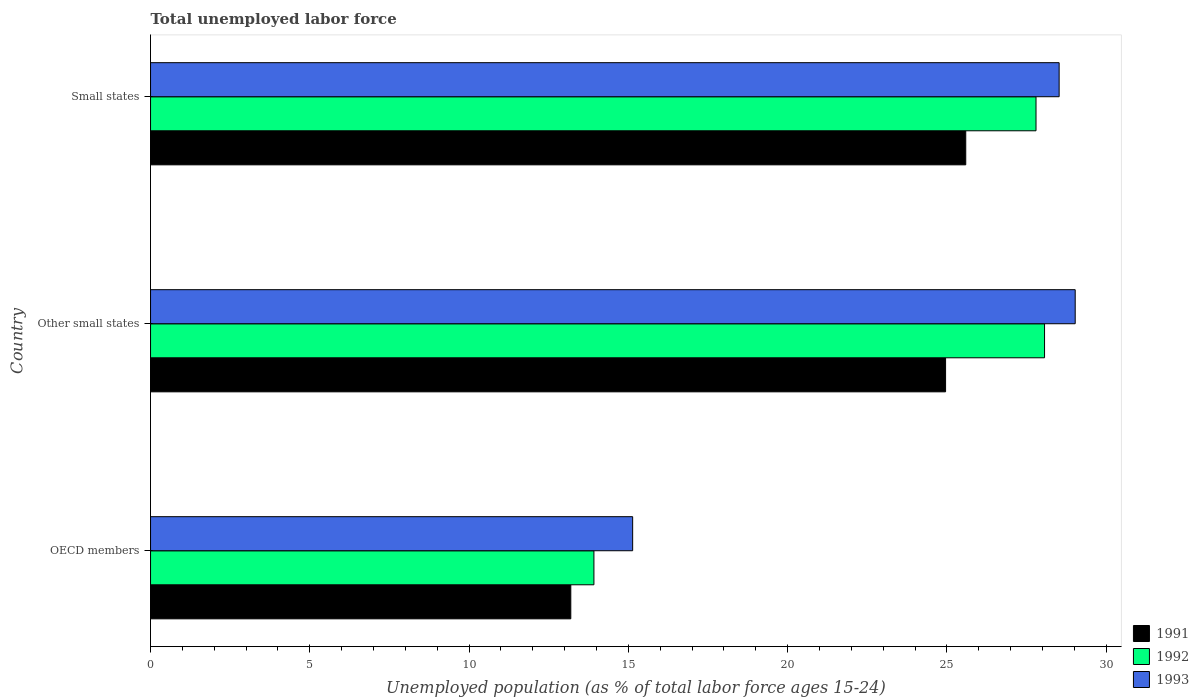Are the number of bars per tick equal to the number of legend labels?
Make the answer very short. Yes. Are the number of bars on each tick of the Y-axis equal?
Keep it short and to the point. Yes. How many bars are there on the 1st tick from the bottom?
Provide a short and direct response. 3. In how many cases, is the number of bars for a given country not equal to the number of legend labels?
Offer a very short reply. 0. What is the percentage of unemployed population in in 1991 in Other small states?
Give a very brief answer. 24.96. Across all countries, what is the maximum percentage of unemployed population in in 1993?
Ensure brevity in your answer.  29.03. Across all countries, what is the minimum percentage of unemployed population in in 1993?
Offer a terse response. 15.13. In which country was the percentage of unemployed population in in 1992 maximum?
Offer a very short reply. Other small states. What is the total percentage of unemployed population in in 1991 in the graph?
Your answer should be very brief. 63.74. What is the difference between the percentage of unemployed population in in 1991 in OECD members and that in Small states?
Offer a very short reply. -12.4. What is the difference between the percentage of unemployed population in in 1992 in Small states and the percentage of unemployed population in in 1993 in OECD members?
Your answer should be compact. 12.66. What is the average percentage of unemployed population in in 1991 per country?
Offer a terse response. 21.25. What is the difference between the percentage of unemployed population in in 1991 and percentage of unemployed population in in 1993 in OECD members?
Offer a very short reply. -1.94. What is the ratio of the percentage of unemployed population in in 1992 in OECD members to that in Small states?
Keep it short and to the point. 0.5. Is the percentage of unemployed population in in 1991 in OECD members less than that in Other small states?
Keep it short and to the point. Yes. What is the difference between the highest and the second highest percentage of unemployed population in in 1993?
Make the answer very short. 0.5. What is the difference between the highest and the lowest percentage of unemployed population in in 1991?
Your answer should be compact. 12.4. Is the sum of the percentage of unemployed population in in 1992 in Other small states and Small states greater than the maximum percentage of unemployed population in in 1991 across all countries?
Make the answer very short. Yes. What does the 1st bar from the top in OECD members represents?
Ensure brevity in your answer.  1993. What does the 3rd bar from the bottom in Other small states represents?
Make the answer very short. 1993. What is the difference between two consecutive major ticks on the X-axis?
Give a very brief answer. 5. Are the values on the major ticks of X-axis written in scientific E-notation?
Provide a short and direct response. No. Does the graph contain grids?
Offer a very short reply. No. Where does the legend appear in the graph?
Keep it short and to the point. Bottom right. How many legend labels are there?
Your response must be concise. 3. What is the title of the graph?
Keep it short and to the point. Total unemployed labor force. Does "1967" appear as one of the legend labels in the graph?
Your answer should be compact. No. What is the label or title of the X-axis?
Your response must be concise. Unemployed population (as % of total labor force ages 15-24). What is the Unemployed population (as % of total labor force ages 15-24) in 1991 in OECD members?
Make the answer very short. 13.19. What is the Unemployed population (as % of total labor force ages 15-24) of 1992 in OECD members?
Your answer should be compact. 13.92. What is the Unemployed population (as % of total labor force ages 15-24) of 1993 in OECD members?
Ensure brevity in your answer.  15.13. What is the Unemployed population (as % of total labor force ages 15-24) in 1991 in Other small states?
Your answer should be very brief. 24.96. What is the Unemployed population (as % of total labor force ages 15-24) of 1992 in Other small states?
Provide a succinct answer. 28.06. What is the Unemployed population (as % of total labor force ages 15-24) in 1993 in Other small states?
Give a very brief answer. 29.03. What is the Unemployed population (as % of total labor force ages 15-24) in 1991 in Small states?
Make the answer very short. 25.59. What is the Unemployed population (as % of total labor force ages 15-24) of 1992 in Small states?
Offer a terse response. 27.8. What is the Unemployed population (as % of total labor force ages 15-24) of 1993 in Small states?
Provide a short and direct response. 28.52. Across all countries, what is the maximum Unemployed population (as % of total labor force ages 15-24) of 1991?
Offer a terse response. 25.59. Across all countries, what is the maximum Unemployed population (as % of total labor force ages 15-24) of 1992?
Your response must be concise. 28.06. Across all countries, what is the maximum Unemployed population (as % of total labor force ages 15-24) of 1993?
Your answer should be compact. 29.03. Across all countries, what is the minimum Unemployed population (as % of total labor force ages 15-24) in 1991?
Give a very brief answer. 13.19. Across all countries, what is the minimum Unemployed population (as % of total labor force ages 15-24) of 1992?
Give a very brief answer. 13.92. Across all countries, what is the minimum Unemployed population (as % of total labor force ages 15-24) in 1993?
Make the answer very short. 15.13. What is the total Unemployed population (as % of total labor force ages 15-24) in 1991 in the graph?
Offer a very short reply. 63.74. What is the total Unemployed population (as % of total labor force ages 15-24) of 1992 in the graph?
Keep it short and to the point. 69.78. What is the total Unemployed population (as % of total labor force ages 15-24) of 1993 in the graph?
Offer a terse response. 72.68. What is the difference between the Unemployed population (as % of total labor force ages 15-24) in 1991 in OECD members and that in Other small states?
Ensure brevity in your answer.  -11.77. What is the difference between the Unemployed population (as % of total labor force ages 15-24) of 1992 in OECD members and that in Other small states?
Offer a very short reply. -14.15. What is the difference between the Unemployed population (as % of total labor force ages 15-24) in 1993 in OECD members and that in Other small states?
Provide a short and direct response. -13.89. What is the difference between the Unemployed population (as % of total labor force ages 15-24) in 1991 in OECD members and that in Small states?
Ensure brevity in your answer.  -12.4. What is the difference between the Unemployed population (as % of total labor force ages 15-24) of 1992 in OECD members and that in Small states?
Offer a very short reply. -13.88. What is the difference between the Unemployed population (as % of total labor force ages 15-24) in 1993 in OECD members and that in Small states?
Your answer should be very brief. -13.39. What is the difference between the Unemployed population (as % of total labor force ages 15-24) of 1991 in Other small states and that in Small states?
Keep it short and to the point. -0.63. What is the difference between the Unemployed population (as % of total labor force ages 15-24) in 1992 in Other small states and that in Small states?
Your response must be concise. 0.27. What is the difference between the Unemployed population (as % of total labor force ages 15-24) in 1993 in Other small states and that in Small states?
Keep it short and to the point. 0.5. What is the difference between the Unemployed population (as % of total labor force ages 15-24) in 1991 in OECD members and the Unemployed population (as % of total labor force ages 15-24) in 1992 in Other small states?
Give a very brief answer. -14.87. What is the difference between the Unemployed population (as % of total labor force ages 15-24) of 1991 in OECD members and the Unemployed population (as % of total labor force ages 15-24) of 1993 in Other small states?
Your answer should be very brief. -15.83. What is the difference between the Unemployed population (as % of total labor force ages 15-24) in 1992 in OECD members and the Unemployed population (as % of total labor force ages 15-24) in 1993 in Other small states?
Provide a short and direct response. -15.11. What is the difference between the Unemployed population (as % of total labor force ages 15-24) of 1991 in OECD members and the Unemployed population (as % of total labor force ages 15-24) of 1992 in Small states?
Provide a short and direct response. -14.6. What is the difference between the Unemployed population (as % of total labor force ages 15-24) in 1991 in OECD members and the Unemployed population (as % of total labor force ages 15-24) in 1993 in Small states?
Ensure brevity in your answer.  -15.33. What is the difference between the Unemployed population (as % of total labor force ages 15-24) of 1992 in OECD members and the Unemployed population (as % of total labor force ages 15-24) of 1993 in Small states?
Ensure brevity in your answer.  -14.6. What is the difference between the Unemployed population (as % of total labor force ages 15-24) of 1991 in Other small states and the Unemployed population (as % of total labor force ages 15-24) of 1992 in Small states?
Provide a succinct answer. -2.84. What is the difference between the Unemployed population (as % of total labor force ages 15-24) in 1991 in Other small states and the Unemployed population (as % of total labor force ages 15-24) in 1993 in Small states?
Offer a very short reply. -3.56. What is the difference between the Unemployed population (as % of total labor force ages 15-24) of 1992 in Other small states and the Unemployed population (as % of total labor force ages 15-24) of 1993 in Small states?
Provide a short and direct response. -0.46. What is the average Unemployed population (as % of total labor force ages 15-24) of 1991 per country?
Keep it short and to the point. 21.25. What is the average Unemployed population (as % of total labor force ages 15-24) of 1992 per country?
Your answer should be very brief. 23.26. What is the average Unemployed population (as % of total labor force ages 15-24) of 1993 per country?
Give a very brief answer. 24.23. What is the difference between the Unemployed population (as % of total labor force ages 15-24) in 1991 and Unemployed population (as % of total labor force ages 15-24) in 1992 in OECD members?
Your answer should be compact. -0.73. What is the difference between the Unemployed population (as % of total labor force ages 15-24) of 1991 and Unemployed population (as % of total labor force ages 15-24) of 1993 in OECD members?
Your response must be concise. -1.94. What is the difference between the Unemployed population (as % of total labor force ages 15-24) in 1992 and Unemployed population (as % of total labor force ages 15-24) in 1993 in OECD members?
Your response must be concise. -1.22. What is the difference between the Unemployed population (as % of total labor force ages 15-24) in 1991 and Unemployed population (as % of total labor force ages 15-24) in 1992 in Other small states?
Provide a short and direct response. -3.11. What is the difference between the Unemployed population (as % of total labor force ages 15-24) of 1991 and Unemployed population (as % of total labor force ages 15-24) of 1993 in Other small states?
Make the answer very short. -4.07. What is the difference between the Unemployed population (as % of total labor force ages 15-24) in 1992 and Unemployed population (as % of total labor force ages 15-24) in 1993 in Other small states?
Provide a short and direct response. -0.96. What is the difference between the Unemployed population (as % of total labor force ages 15-24) of 1991 and Unemployed population (as % of total labor force ages 15-24) of 1992 in Small states?
Keep it short and to the point. -2.21. What is the difference between the Unemployed population (as % of total labor force ages 15-24) in 1991 and Unemployed population (as % of total labor force ages 15-24) in 1993 in Small states?
Ensure brevity in your answer.  -2.93. What is the difference between the Unemployed population (as % of total labor force ages 15-24) in 1992 and Unemployed population (as % of total labor force ages 15-24) in 1993 in Small states?
Offer a very short reply. -0.73. What is the ratio of the Unemployed population (as % of total labor force ages 15-24) of 1991 in OECD members to that in Other small states?
Provide a succinct answer. 0.53. What is the ratio of the Unemployed population (as % of total labor force ages 15-24) of 1992 in OECD members to that in Other small states?
Your response must be concise. 0.5. What is the ratio of the Unemployed population (as % of total labor force ages 15-24) in 1993 in OECD members to that in Other small states?
Your response must be concise. 0.52. What is the ratio of the Unemployed population (as % of total labor force ages 15-24) of 1991 in OECD members to that in Small states?
Offer a very short reply. 0.52. What is the ratio of the Unemployed population (as % of total labor force ages 15-24) in 1992 in OECD members to that in Small states?
Offer a terse response. 0.5. What is the ratio of the Unemployed population (as % of total labor force ages 15-24) of 1993 in OECD members to that in Small states?
Provide a short and direct response. 0.53. What is the ratio of the Unemployed population (as % of total labor force ages 15-24) in 1991 in Other small states to that in Small states?
Your answer should be compact. 0.98. What is the ratio of the Unemployed population (as % of total labor force ages 15-24) in 1992 in Other small states to that in Small states?
Keep it short and to the point. 1.01. What is the ratio of the Unemployed population (as % of total labor force ages 15-24) in 1993 in Other small states to that in Small states?
Provide a succinct answer. 1.02. What is the difference between the highest and the second highest Unemployed population (as % of total labor force ages 15-24) in 1991?
Keep it short and to the point. 0.63. What is the difference between the highest and the second highest Unemployed population (as % of total labor force ages 15-24) of 1992?
Give a very brief answer. 0.27. What is the difference between the highest and the second highest Unemployed population (as % of total labor force ages 15-24) in 1993?
Keep it short and to the point. 0.5. What is the difference between the highest and the lowest Unemployed population (as % of total labor force ages 15-24) in 1991?
Your response must be concise. 12.4. What is the difference between the highest and the lowest Unemployed population (as % of total labor force ages 15-24) in 1992?
Offer a terse response. 14.15. What is the difference between the highest and the lowest Unemployed population (as % of total labor force ages 15-24) of 1993?
Keep it short and to the point. 13.89. 